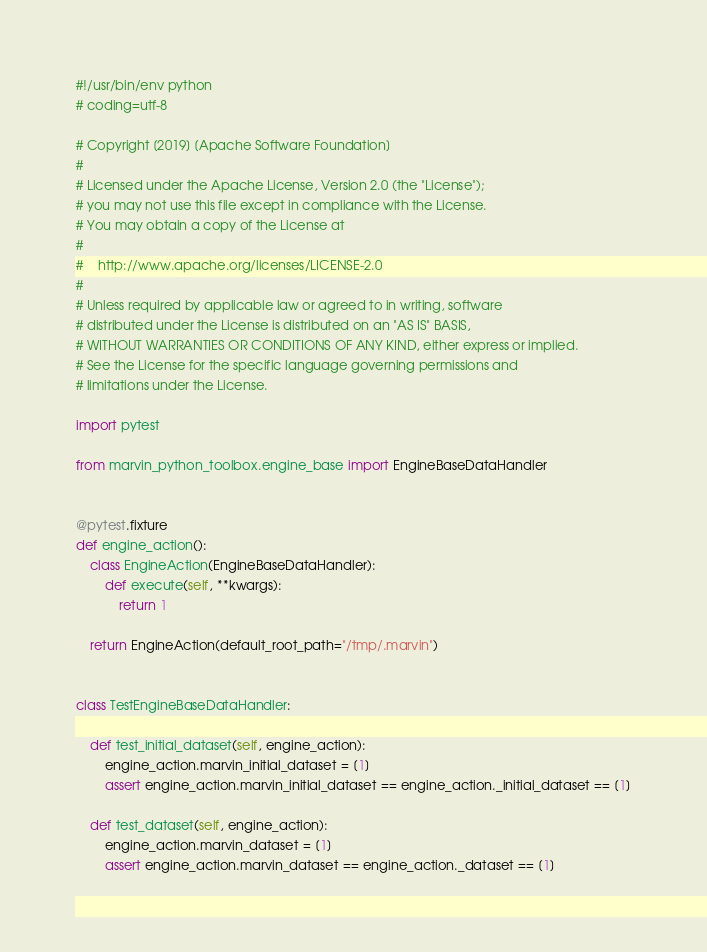<code> <loc_0><loc_0><loc_500><loc_500><_Python_>#!/usr/bin/env python
# coding=utf-8

# Copyright [2019] [Apache Software Foundation]
#
# Licensed under the Apache License, Version 2.0 (the "License");
# you may not use this file except in compliance with the License.
# You may obtain a copy of the License at
#
#    http://www.apache.org/licenses/LICENSE-2.0
#
# Unless required by applicable law or agreed to in writing, software
# distributed under the License is distributed on an "AS IS" BASIS,
# WITHOUT WARRANTIES OR CONDITIONS OF ANY KIND, either express or implied.
# See the License for the specific language governing permissions and
# limitations under the License.

import pytest

from marvin_python_toolbox.engine_base import EngineBaseDataHandler


@pytest.fixture
def engine_action():
    class EngineAction(EngineBaseDataHandler):
        def execute(self, **kwargs):
            return 1

    return EngineAction(default_root_path="/tmp/.marvin")


class TestEngineBaseDataHandler:

    def test_initial_dataset(self, engine_action):
        engine_action.marvin_initial_dataset = [1]
        assert engine_action.marvin_initial_dataset == engine_action._initial_dataset == [1]

    def test_dataset(self, engine_action):
        engine_action.marvin_dataset = [1]
        assert engine_action.marvin_dataset == engine_action._dataset == [1]
</code> 